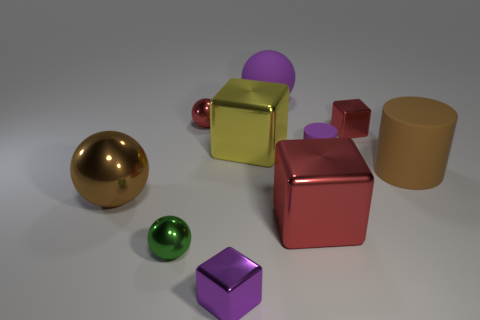Subtract 1 blocks. How many blocks are left? 3 Subtract all cylinders. How many objects are left? 8 Subtract all cyan matte spheres. Subtract all small rubber things. How many objects are left? 9 Add 3 small rubber objects. How many small rubber objects are left? 4 Add 5 small red things. How many small red things exist? 7 Subtract 1 brown spheres. How many objects are left? 9 